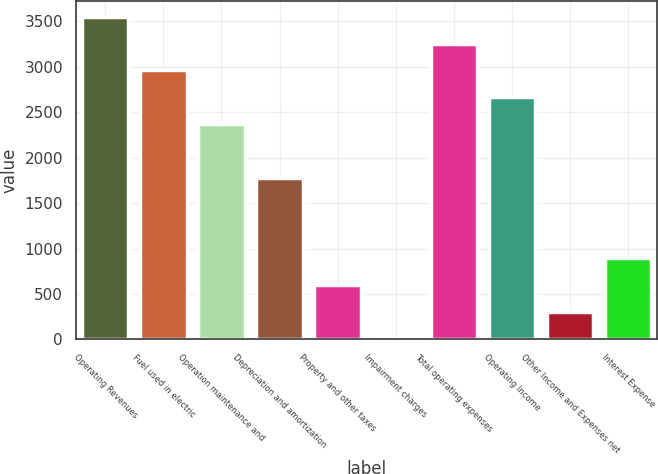Convert chart. <chart><loc_0><loc_0><loc_500><loc_500><bar_chart><fcel>Operating Revenues<fcel>Fuel used in electric<fcel>Operation maintenance and<fcel>Depreciation and amortization<fcel>Property and other taxes<fcel>Impairment charges<fcel>Total operating expenses<fcel>Operating Income<fcel>Other Income and Expenses net<fcel>Interest Expense<nl><fcel>3548<fcel>2958<fcel>2368<fcel>1778<fcel>598<fcel>8<fcel>3253<fcel>2663<fcel>303<fcel>893<nl></chart> 